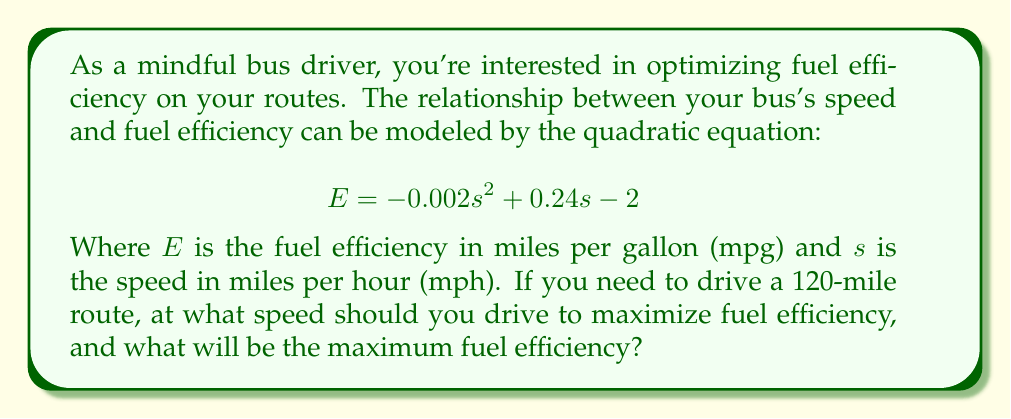Help me with this question. To solve this problem, we'll follow these steps:

1) The given quadratic equation for fuel efficiency is:
   $$ E = -0.002s^2 + 0.24s - 2 $$

2) To find the maximum value of this quadratic function, we need to find the vertex of the parabola. The s-coordinate of the vertex will give us the optimal speed, and the E-coordinate will give us the maximum fuel efficiency.

3) For a quadratic equation in the form $ax^2 + bx + c$, the s-coordinate of the vertex is given by $s = -\frac{b}{2a}$

4) In our equation, $a = -0.002$ and $b = 0.24$. Let's substitute these values:

   $$ s = -\frac{0.24}{2(-0.002)} = \frac{0.24}{0.004} = 60 $$

5) So, the optimal speed is 60 mph.

6) To find the maximum fuel efficiency, we substitute this speed back into our original equation:

   $$ E = -0.002(60)^2 + 0.24(60) - 2 $$
   $$ E = -0.002(3600) + 14.4 - 2 $$
   $$ E = -7.2 + 14.4 - 2 $$
   $$ E = 5.2 $$

7) Therefore, the maximum fuel efficiency is 5.2 mpg.

8) The question about driving a 120-mile route is included to make the problem more relevant to a bus driver, but it doesn't affect the calculation of the optimal speed or maximum efficiency.
Answer: The optimal speed to maximize fuel efficiency is 60 mph, and the maximum fuel efficiency at this speed is 5.2 mpg. 